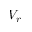<formula> <loc_0><loc_0><loc_500><loc_500>V _ { r }</formula> 